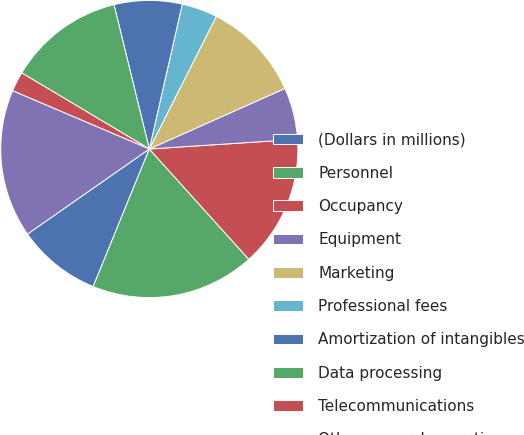<chart> <loc_0><loc_0><loc_500><loc_500><pie_chart><fcel>(Dollars in millions)<fcel>Personnel<fcel>Occupancy<fcel>Equipment<fcel>Marketing<fcel>Professional fees<fcel>Amortization of intangibles<fcel>Data processing<fcel>Telecommunications<fcel>Other general operating<nl><fcel>9.13%<fcel>17.85%<fcel>14.36%<fcel>5.64%<fcel>10.87%<fcel>3.89%<fcel>7.38%<fcel>12.62%<fcel>2.15%<fcel>16.11%<nl></chart> 